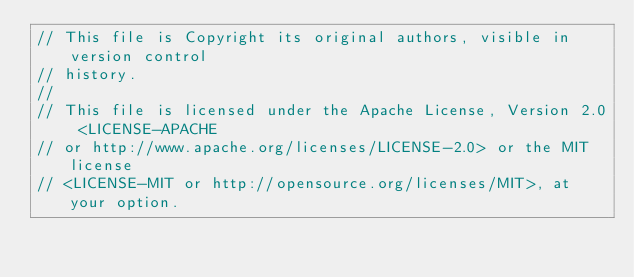Convert code to text. <code><loc_0><loc_0><loc_500><loc_500><_Rust_>// This file is Copyright its original authors, visible in version control
// history.
//
// This file is licensed under the Apache License, Version 2.0 <LICENSE-APACHE
// or http://www.apache.org/licenses/LICENSE-2.0> or the MIT license
// <LICENSE-MIT or http://opensource.org/licenses/MIT>, at your option.</code> 